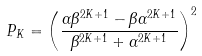Convert formula to latex. <formula><loc_0><loc_0><loc_500><loc_500>P _ { K } = \left ( \frac { \alpha \beta ^ { 2 K + 1 } - \beta \alpha ^ { 2 K + 1 } } { \beta ^ { 2 K + 1 } + \alpha ^ { 2 K + 1 } } \right ) ^ { 2 }</formula> 